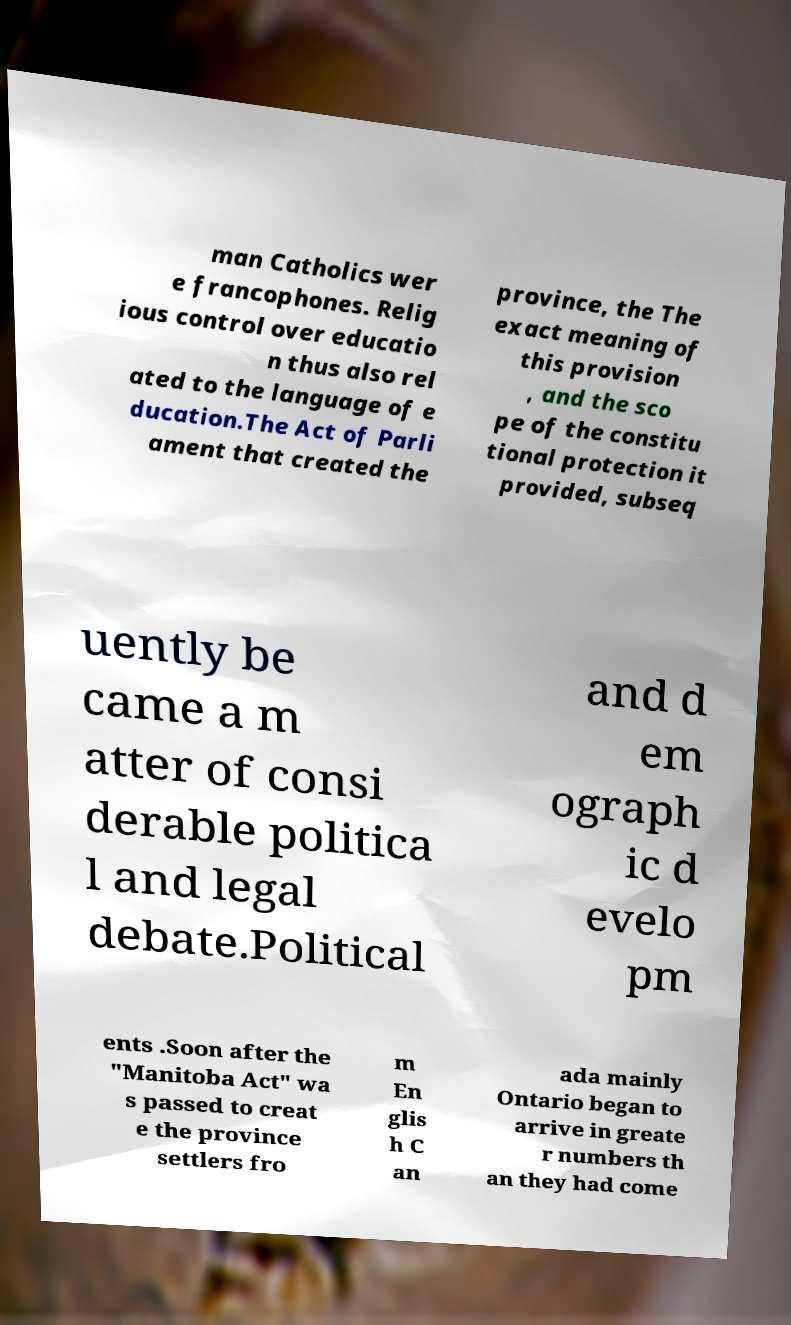What messages or text are displayed in this image? I need them in a readable, typed format. man Catholics wer e francophones. Relig ious control over educatio n thus also rel ated to the language of e ducation.The Act of Parli ament that created the province, the The exact meaning of this provision , and the sco pe of the constitu tional protection it provided, subseq uently be came a m atter of consi derable politica l and legal debate.Political and d em ograph ic d evelo pm ents .Soon after the "Manitoba Act" wa s passed to creat e the province settlers fro m En glis h C an ada mainly Ontario began to arrive in greate r numbers th an they had come 